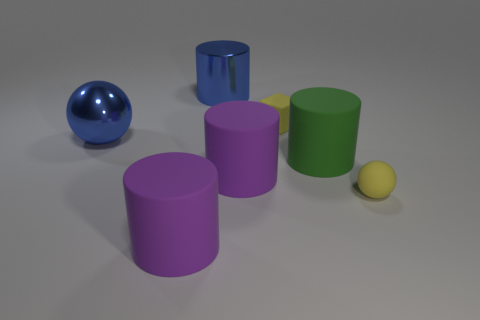Subtract all big blue cylinders. How many cylinders are left? 3 Subtract all yellow spheres. How many spheres are left? 1 Subtract all blue blocks. Subtract all brown cylinders. How many blocks are left? 1 Subtract all red spheres. How many red cylinders are left? 0 Subtract all large cyan rubber cylinders. Subtract all large purple things. How many objects are left? 5 Add 4 matte cylinders. How many matte cylinders are left? 7 Add 3 tiny rubber cubes. How many tiny rubber cubes exist? 4 Add 1 small yellow rubber cubes. How many objects exist? 8 Subtract 0 gray cylinders. How many objects are left? 7 Subtract all blocks. How many objects are left? 6 